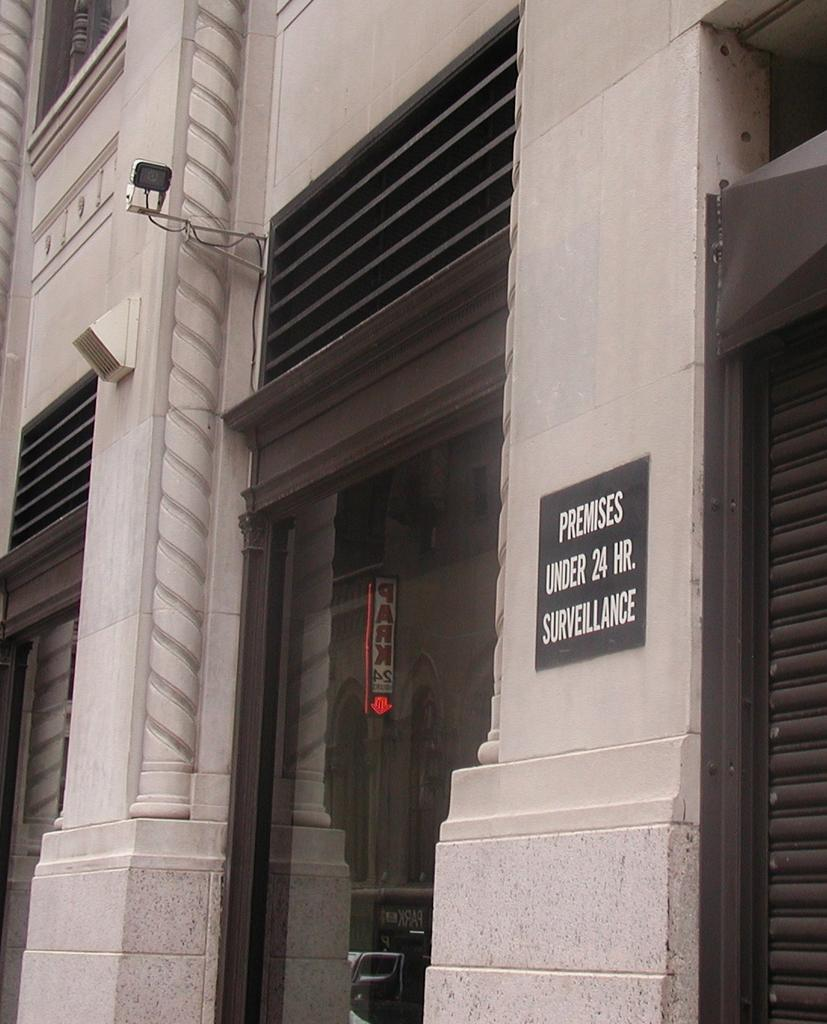What type of structure is in the image? There is a building in the image. What material is present in the image? Glass is present in the image. What feature can be seen on the building? There is a shutter in the image. What source of illumination is visible in the image? There is a light in the image. What type of signage is visible in the image? Name boards are visible in the image. Can you describe any other objects in the image? There are some unspecified objects in the image. Where can the fairies be seen playing in the image? There are no fairies present in the image. What type of alley is visible in the image? There is no alley present in the image. 